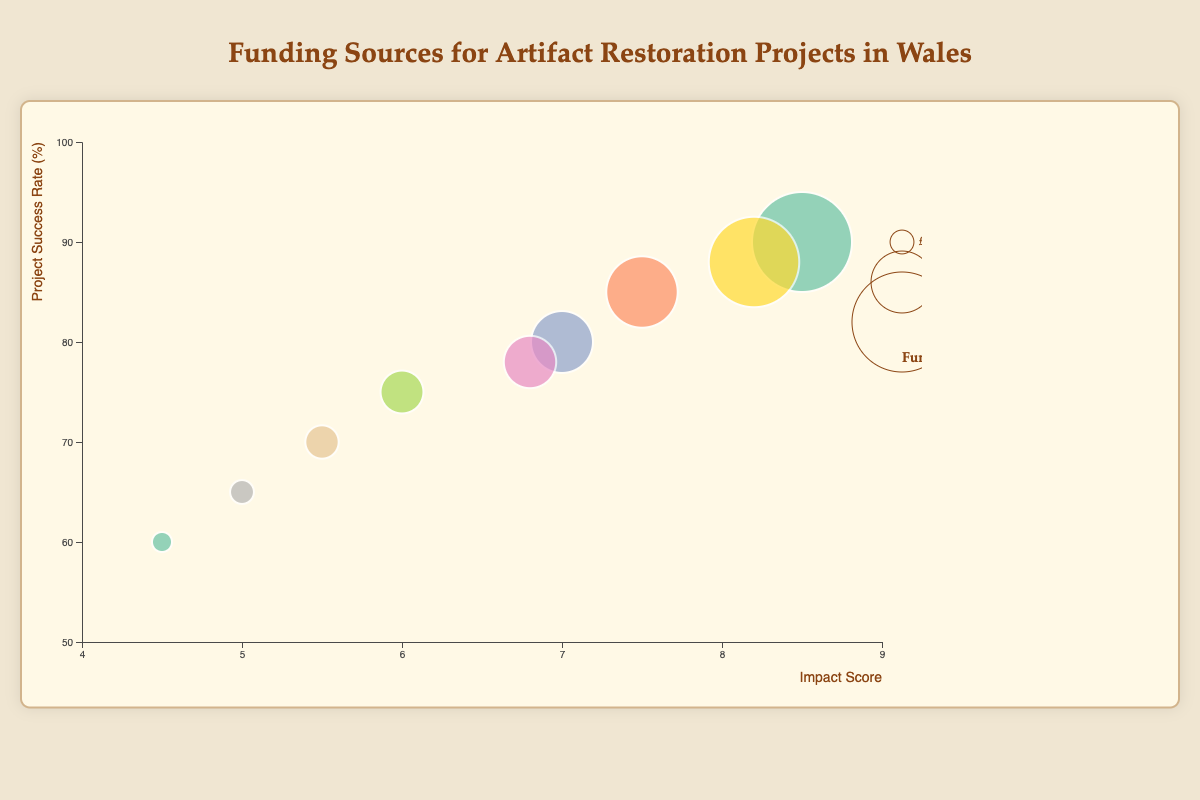What is the title of the figure? The title is located at the top center of the figure. It reads "Funding Sources for Artifact Restoration Projects in Wales".
Answer: Funding Sources for Artifact Restoration Projects in Wales What does the x-axis represent? The x-axis label is at the bottom of the figure, and it reads "Impact Score", indicating that the x-axis represents the impact score of the funding sources.
Answer: Impact Score Which funding source has the highest project success rate? By examining the y-axis representing the project success rate and looking for the highest positioned circle, we can see that the "Heritage Lottery Fund" has the highest project success rate of 90%.
Answer: Heritage Lottery Fund How many funding sources are represented in the chart? Each funding source is represented by a unique bubble. There are nine circles indicating nine different funding sources.
Answer: 9 Which funding source has the largest bubble and what does this represent? The largest bubble size corresponds to the amount of funding. By inspecting the circle sizes, "Heritage Lottery Fund" has the largest bubble, representing the highest funding amount of £500,000.
Answer: Heritage Lottery Fund What is the impact score of "Cadw" and how does it compare to "Arts Council of Wales"? By locating the positions of "Cadw" and "Arts Council of Wales" along the x-axis, we see "Cadw" has an impact score of 6.8 while "Arts Council of Wales" has an impact score of 6.0. "Cadw" has a higher impact score.
Answer: Cadw's impact score is 6.8; it is higher than Arts Council of Wales's 6.0 Which funding source has the lowest project success rate? By checking the y-axis for the lowest position of a circle, "Crowdfunding" has the lowest project success rate of 60%.
Answer: Crowdfunding Compare the project success rates of "EU Structural Funds" and "Welsh Government". Which has a higher rate and by how much? "EU Structural Funds" has a project success rate of 88%, while "Welsh Government" has a rate of 80%. The difference is 88% - 80% = 8%.
Answer: EU Structural Funds has a higher rate by 8% What is the total amount of funding represented in this chart? Adding up the funding amounts for all sources: £500,000 + £350,000 + £300,000 + £250,000 + £200,000 + £450,000 + £150,000 + £100,000 + £80,000 = £2,380,000.
Answer: £2,380,000 Which funding source is closest to having an impact score of 7.0? The "Welsh Government" has an impact score of exactly 7.0, placing it closest to that value.
Answer: Welsh Government 